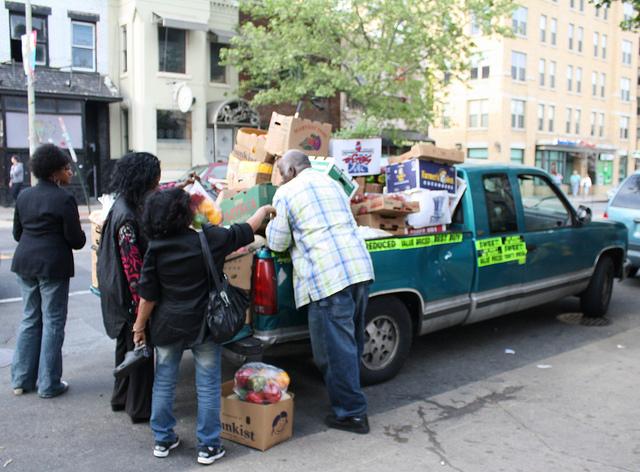What is the company's slogan?
Concise answer only. Cannot read. What type of shoes is the lady holding the purse wearing?
Quick response, please. Sneakers. What color are the stickers on the side of the truck?
Short answer required. Green. Is the guy's shirt plaid?
Write a very short answer. Yes. 